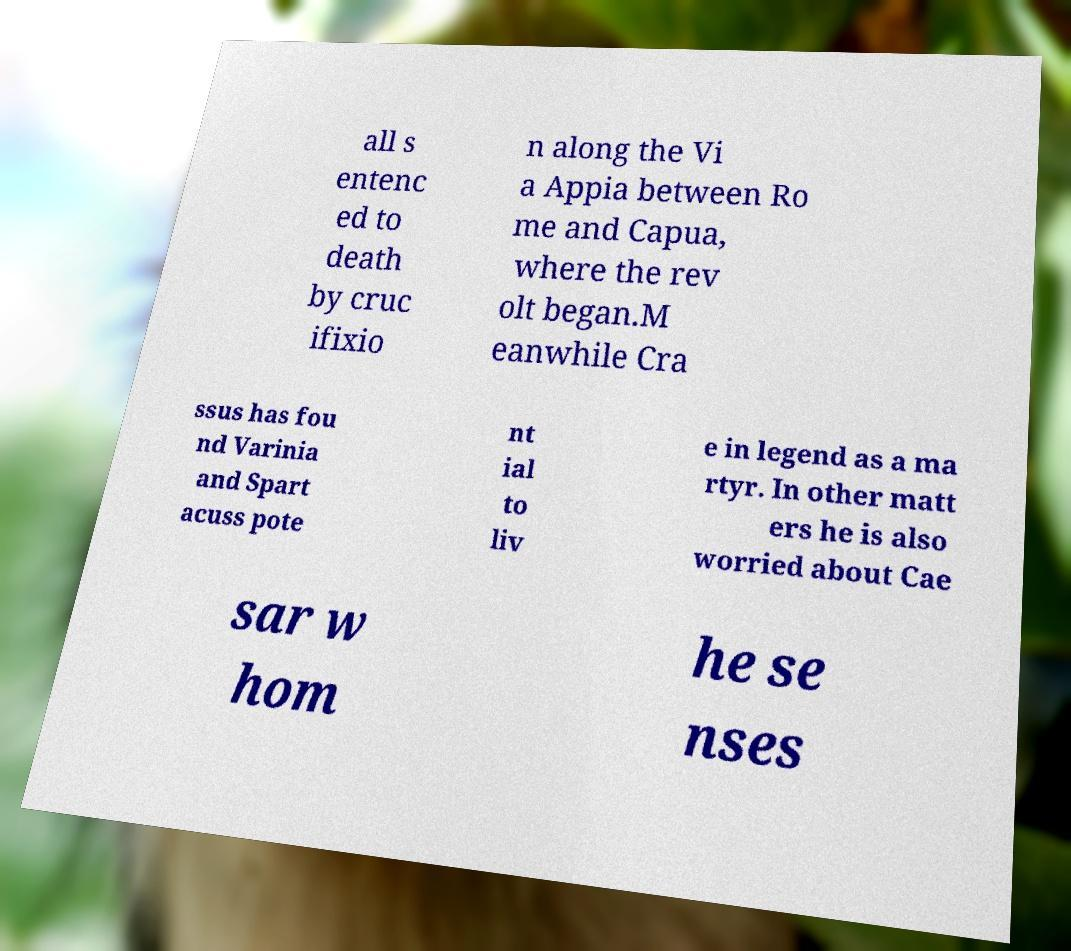I need the written content from this picture converted into text. Can you do that? all s entenc ed to death by cruc ifixio n along the Vi a Appia between Ro me and Capua, where the rev olt began.M eanwhile Cra ssus has fou nd Varinia and Spart acuss pote nt ial to liv e in legend as a ma rtyr. In other matt ers he is also worried about Cae sar w hom he se nses 